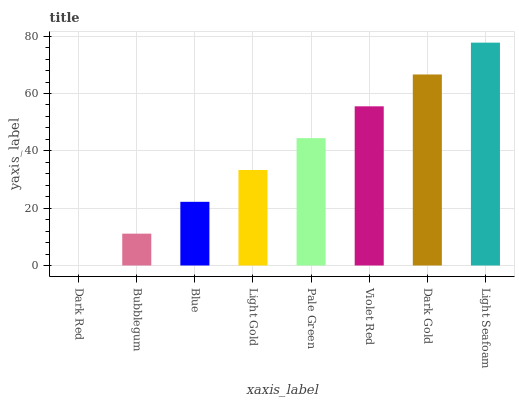Is Dark Red the minimum?
Answer yes or no. Yes. Is Light Seafoam the maximum?
Answer yes or no. Yes. Is Bubblegum the minimum?
Answer yes or no. No. Is Bubblegum the maximum?
Answer yes or no. No. Is Bubblegum greater than Dark Red?
Answer yes or no. Yes. Is Dark Red less than Bubblegum?
Answer yes or no. Yes. Is Dark Red greater than Bubblegum?
Answer yes or no. No. Is Bubblegum less than Dark Red?
Answer yes or no. No. Is Pale Green the high median?
Answer yes or no. Yes. Is Light Gold the low median?
Answer yes or no. Yes. Is Blue the high median?
Answer yes or no. No. Is Light Seafoam the low median?
Answer yes or no. No. 